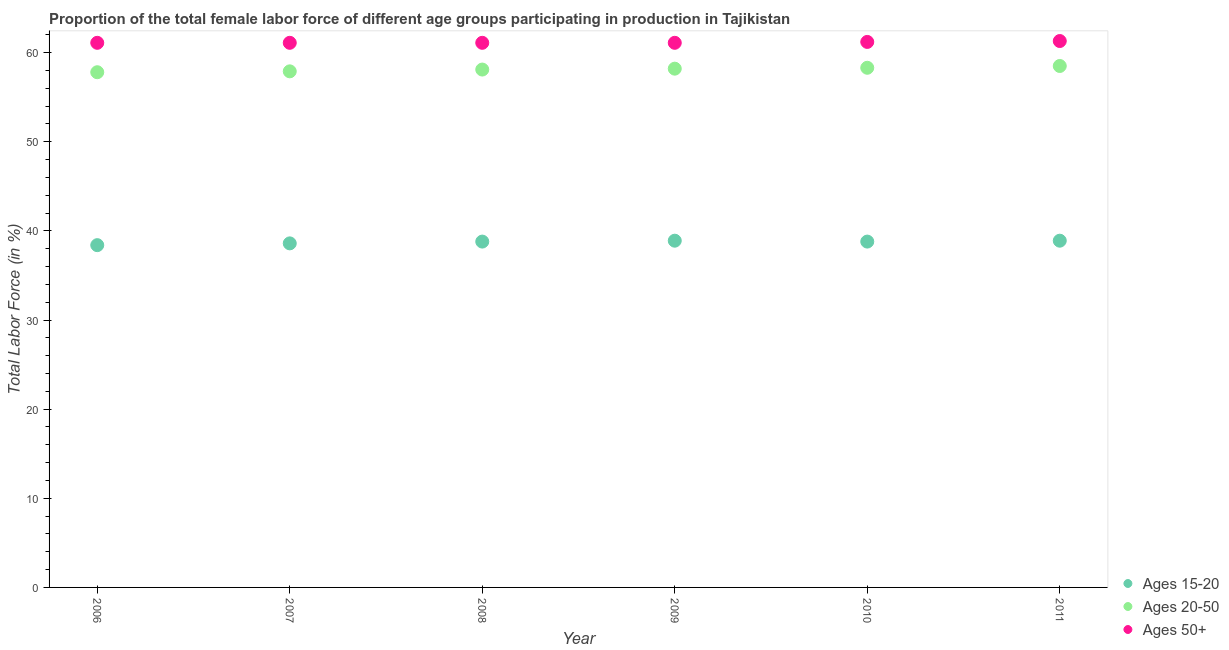How many different coloured dotlines are there?
Keep it short and to the point. 3. What is the percentage of female labor force within the age group 20-50 in 2009?
Your answer should be very brief. 58.2. Across all years, what is the maximum percentage of female labor force above age 50?
Provide a succinct answer. 61.3. Across all years, what is the minimum percentage of female labor force within the age group 15-20?
Keep it short and to the point. 38.4. In which year was the percentage of female labor force within the age group 15-20 minimum?
Give a very brief answer. 2006. What is the total percentage of female labor force within the age group 15-20 in the graph?
Your answer should be very brief. 232.4. What is the difference between the percentage of female labor force within the age group 20-50 in 2009 and that in 2010?
Your answer should be compact. -0.1. What is the difference between the percentage of female labor force within the age group 15-20 in 2006 and the percentage of female labor force within the age group 20-50 in 2009?
Your answer should be compact. -19.8. What is the average percentage of female labor force above age 50 per year?
Provide a succinct answer. 61.15. In the year 2008, what is the difference between the percentage of female labor force above age 50 and percentage of female labor force within the age group 15-20?
Ensure brevity in your answer.  22.3. Is the difference between the percentage of female labor force within the age group 20-50 in 2008 and 2010 greater than the difference between the percentage of female labor force within the age group 15-20 in 2008 and 2010?
Make the answer very short. No. What is the difference between the highest and the second highest percentage of female labor force within the age group 20-50?
Make the answer very short. 0.2. What is the difference between the highest and the lowest percentage of female labor force within the age group 15-20?
Your answer should be very brief. 0.5. Is the sum of the percentage of female labor force within the age group 20-50 in 2006 and 2010 greater than the maximum percentage of female labor force above age 50 across all years?
Make the answer very short. Yes. Does the percentage of female labor force above age 50 monotonically increase over the years?
Ensure brevity in your answer.  No. How many years are there in the graph?
Provide a succinct answer. 6. What is the difference between two consecutive major ticks on the Y-axis?
Your answer should be compact. 10. Where does the legend appear in the graph?
Your answer should be very brief. Bottom right. How many legend labels are there?
Your answer should be compact. 3. How are the legend labels stacked?
Your answer should be compact. Vertical. What is the title of the graph?
Provide a succinct answer. Proportion of the total female labor force of different age groups participating in production in Tajikistan. What is the label or title of the Y-axis?
Your response must be concise. Total Labor Force (in %). What is the Total Labor Force (in %) of Ages 15-20 in 2006?
Provide a succinct answer. 38.4. What is the Total Labor Force (in %) of Ages 20-50 in 2006?
Your answer should be compact. 57.8. What is the Total Labor Force (in %) of Ages 50+ in 2006?
Ensure brevity in your answer.  61.1. What is the Total Labor Force (in %) of Ages 15-20 in 2007?
Your answer should be compact. 38.6. What is the Total Labor Force (in %) of Ages 20-50 in 2007?
Your answer should be compact. 57.9. What is the Total Labor Force (in %) in Ages 50+ in 2007?
Keep it short and to the point. 61.1. What is the Total Labor Force (in %) in Ages 15-20 in 2008?
Your response must be concise. 38.8. What is the Total Labor Force (in %) in Ages 20-50 in 2008?
Keep it short and to the point. 58.1. What is the Total Labor Force (in %) in Ages 50+ in 2008?
Make the answer very short. 61.1. What is the Total Labor Force (in %) of Ages 15-20 in 2009?
Offer a very short reply. 38.9. What is the Total Labor Force (in %) in Ages 20-50 in 2009?
Ensure brevity in your answer.  58.2. What is the Total Labor Force (in %) in Ages 50+ in 2009?
Give a very brief answer. 61.1. What is the Total Labor Force (in %) in Ages 15-20 in 2010?
Offer a very short reply. 38.8. What is the Total Labor Force (in %) of Ages 20-50 in 2010?
Your response must be concise. 58.3. What is the Total Labor Force (in %) in Ages 50+ in 2010?
Provide a short and direct response. 61.2. What is the Total Labor Force (in %) in Ages 15-20 in 2011?
Make the answer very short. 38.9. What is the Total Labor Force (in %) in Ages 20-50 in 2011?
Make the answer very short. 58.5. What is the Total Labor Force (in %) of Ages 50+ in 2011?
Provide a short and direct response. 61.3. Across all years, what is the maximum Total Labor Force (in %) in Ages 15-20?
Offer a very short reply. 38.9. Across all years, what is the maximum Total Labor Force (in %) in Ages 20-50?
Provide a succinct answer. 58.5. Across all years, what is the maximum Total Labor Force (in %) of Ages 50+?
Make the answer very short. 61.3. Across all years, what is the minimum Total Labor Force (in %) of Ages 15-20?
Offer a terse response. 38.4. Across all years, what is the minimum Total Labor Force (in %) in Ages 20-50?
Make the answer very short. 57.8. Across all years, what is the minimum Total Labor Force (in %) in Ages 50+?
Give a very brief answer. 61.1. What is the total Total Labor Force (in %) in Ages 15-20 in the graph?
Provide a short and direct response. 232.4. What is the total Total Labor Force (in %) in Ages 20-50 in the graph?
Your answer should be compact. 348.8. What is the total Total Labor Force (in %) in Ages 50+ in the graph?
Offer a very short reply. 366.9. What is the difference between the Total Labor Force (in %) in Ages 20-50 in 2006 and that in 2007?
Ensure brevity in your answer.  -0.1. What is the difference between the Total Labor Force (in %) of Ages 50+ in 2006 and that in 2007?
Your answer should be very brief. 0. What is the difference between the Total Labor Force (in %) of Ages 50+ in 2006 and that in 2008?
Provide a succinct answer. 0. What is the difference between the Total Labor Force (in %) of Ages 15-20 in 2006 and that in 2009?
Give a very brief answer. -0.5. What is the difference between the Total Labor Force (in %) in Ages 20-50 in 2006 and that in 2009?
Offer a very short reply. -0.4. What is the difference between the Total Labor Force (in %) of Ages 50+ in 2006 and that in 2009?
Provide a short and direct response. 0. What is the difference between the Total Labor Force (in %) of Ages 15-20 in 2006 and that in 2011?
Ensure brevity in your answer.  -0.5. What is the difference between the Total Labor Force (in %) in Ages 20-50 in 2006 and that in 2011?
Ensure brevity in your answer.  -0.7. What is the difference between the Total Labor Force (in %) of Ages 50+ in 2007 and that in 2008?
Make the answer very short. 0. What is the difference between the Total Labor Force (in %) in Ages 15-20 in 2007 and that in 2009?
Your answer should be compact. -0.3. What is the difference between the Total Labor Force (in %) of Ages 20-50 in 2007 and that in 2010?
Keep it short and to the point. -0.4. What is the difference between the Total Labor Force (in %) in Ages 20-50 in 2008 and that in 2009?
Offer a terse response. -0.1. What is the difference between the Total Labor Force (in %) in Ages 50+ in 2008 and that in 2009?
Provide a succinct answer. 0. What is the difference between the Total Labor Force (in %) in Ages 15-20 in 2008 and that in 2010?
Offer a terse response. 0. What is the difference between the Total Labor Force (in %) in Ages 50+ in 2008 and that in 2010?
Your response must be concise. -0.1. What is the difference between the Total Labor Force (in %) in Ages 15-20 in 2008 and that in 2011?
Ensure brevity in your answer.  -0.1. What is the difference between the Total Labor Force (in %) of Ages 20-50 in 2008 and that in 2011?
Offer a very short reply. -0.4. What is the difference between the Total Labor Force (in %) in Ages 15-20 in 2009 and that in 2010?
Your response must be concise. 0.1. What is the difference between the Total Labor Force (in %) in Ages 15-20 in 2009 and that in 2011?
Your response must be concise. 0. What is the difference between the Total Labor Force (in %) in Ages 20-50 in 2009 and that in 2011?
Offer a terse response. -0.3. What is the difference between the Total Labor Force (in %) in Ages 15-20 in 2006 and the Total Labor Force (in %) in Ages 20-50 in 2007?
Offer a terse response. -19.5. What is the difference between the Total Labor Force (in %) of Ages 15-20 in 2006 and the Total Labor Force (in %) of Ages 50+ in 2007?
Make the answer very short. -22.7. What is the difference between the Total Labor Force (in %) in Ages 15-20 in 2006 and the Total Labor Force (in %) in Ages 20-50 in 2008?
Ensure brevity in your answer.  -19.7. What is the difference between the Total Labor Force (in %) in Ages 15-20 in 2006 and the Total Labor Force (in %) in Ages 50+ in 2008?
Give a very brief answer. -22.7. What is the difference between the Total Labor Force (in %) of Ages 20-50 in 2006 and the Total Labor Force (in %) of Ages 50+ in 2008?
Make the answer very short. -3.3. What is the difference between the Total Labor Force (in %) of Ages 15-20 in 2006 and the Total Labor Force (in %) of Ages 20-50 in 2009?
Provide a succinct answer. -19.8. What is the difference between the Total Labor Force (in %) of Ages 15-20 in 2006 and the Total Labor Force (in %) of Ages 50+ in 2009?
Your answer should be very brief. -22.7. What is the difference between the Total Labor Force (in %) in Ages 15-20 in 2006 and the Total Labor Force (in %) in Ages 20-50 in 2010?
Give a very brief answer. -19.9. What is the difference between the Total Labor Force (in %) of Ages 15-20 in 2006 and the Total Labor Force (in %) of Ages 50+ in 2010?
Ensure brevity in your answer.  -22.8. What is the difference between the Total Labor Force (in %) of Ages 15-20 in 2006 and the Total Labor Force (in %) of Ages 20-50 in 2011?
Offer a very short reply. -20.1. What is the difference between the Total Labor Force (in %) in Ages 15-20 in 2006 and the Total Labor Force (in %) in Ages 50+ in 2011?
Offer a terse response. -22.9. What is the difference between the Total Labor Force (in %) of Ages 15-20 in 2007 and the Total Labor Force (in %) of Ages 20-50 in 2008?
Offer a very short reply. -19.5. What is the difference between the Total Labor Force (in %) of Ages 15-20 in 2007 and the Total Labor Force (in %) of Ages 50+ in 2008?
Provide a succinct answer. -22.5. What is the difference between the Total Labor Force (in %) of Ages 20-50 in 2007 and the Total Labor Force (in %) of Ages 50+ in 2008?
Offer a very short reply. -3.2. What is the difference between the Total Labor Force (in %) in Ages 15-20 in 2007 and the Total Labor Force (in %) in Ages 20-50 in 2009?
Keep it short and to the point. -19.6. What is the difference between the Total Labor Force (in %) of Ages 15-20 in 2007 and the Total Labor Force (in %) of Ages 50+ in 2009?
Your answer should be very brief. -22.5. What is the difference between the Total Labor Force (in %) of Ages 15-20 in 2007 and the Total Labor Force (in %) of Ages 20-50 in 2010?
Give a very brief answer. -19.7. What is the difference between the Total Labor Force (in %) of Ages 15-20 in 2007 and the Total Labor Force (in %) of Ages 50+ in 2010?
Your answer should be compact. -22.6. What is the difference between the Total Labor Force (in %) in Ages 20-50 in 2007 and the Total Labor Force (in %) in Ages 50+ in 2010?
Your response must be concise. -3.3. What is the difference between the Total Labor Force (in %) in Ages 15-20 in 2007 and the Total Labor Force (in %) in Ages 20-50 in 2011?
Your answer should be very brief. -19.9. What is the difference between the Total Labor Force (in %) in Ages 15-20 in 2007 and the Total Labor Force (in %) in Ages 50+ in 2011?
Ensure brevity in your answer.  -22.7. What is the difference between the Total Labor Force (in %) of Ages 15-20 in 2008 and the Total Labor Force (in %) of Ages 20-50 in 2009?
Make the answer very short. -19.4. What is the difference between the Total Labor Force (in %) of Ages 15-20 in 2008 and the Total Labor Force (in %) of Ages 50+ in 2009?
Offer a terse response. -22.3. What is the difference between the Total Labor Force (in %) in Ages 20-50 in 2008 and the Total Labor Force (in %) in Ages 50+ in 2009?
Keep it short and to the point. -3. What is the difference between the Total Labor Force (in %) in Ages 15-20 in 2008 and the Total Labor Force (in %) in Ages 20-50 in 2010?
Your answer should be very brief. -19.5. What is the difference between the Total Labor Force (in %) in Ages 15-20 in 2008 and the Total Labor Force (in %) in Ages 50+ in 2010?
Offer a terse response. -22.4. What is the difference between the Total Labor Force (in %) of Ages 20-50 in 2008 and the Total Labor Force (in %) of Ages 50+ in 2010?
Make the answer very short. -3.1. What is the difference between the Total Labor Force (in %) of Ages 15-20 in 2008 and the Total Labor Force (in %) of Ages 20-50 in 2011?
Give a very brief answer. -19.7. What is the difference between the Total Labor Force (in %) of Ages 15-20 in 2008 and the Total Labor Force (in %) of Ages 50+ in 2011?
Keep it short and to the point. -22.5. What is the difference between the Total Labor Force (in %) in Ages 20-50 in 2008 and the Total Labor Force (in %) in Ages 50+ in 2011?
Give a very brief answer. -3.2. What is the difference between the Total Labor Force (in %) in Ages 15-20 in 2009 and the Total Labor Force (in %) in Ages 20-50 in 2010?
Offer a very short reply. -19.4. What is the difference between the Total Labor Force (in %) in Ages 15-20 in 2009 and the Total Labor Force (in %) in Ages 50+ in 2010?
Provide a short and direct response. -22.3. What is the difference between the Total Labor Force (in %) in Ages 15-20 in 2009 and the Total Labor Force (in %) in Ages 20-50 in 2011?
Make the answer very short. -19.6. What is the difference between the Total Labor Force (in %) of Ages 15-20 in 2009 and the Total Labor Force (in %) of Ages 50+ in 2011?
Keep it short and to the point. -22.4. What is the difference between the Total Labor Force (in %) of Ages 20-50 in 2009 and the Total Labor Force (in %) of Ages 50+ in 2011?
Provide a succinct answer. -3.1. What is the difference between the Total Labor Force (in %) of Ages 15-20 in 2010 and the Total Labor Force (in %) of Ages 20-50 in 2011?
Provide a short and direct response. -19.7. What is the difference between the Total Labor Force (in %) of Ages 15-20 in 2010 and the Total Labor Force (in %) of Ages 50+ in 2011?
Provide a short and direct response. -22.5. What is the difference between the Total Labor Force (in %) in Ages 20-50 in 2010 and the Total Labor Force (in %) in Ages 50+ in 2011?
Provide a short and direct response. -3. What is the average Total Labor Force (in %) of Ages 15-20 per year?
Provide a short and direct response. 38.73. What is the average Total Labor Force (in %) of Ages 20-50 per year?
Your response must be concise. 58.13. What is the average Total Labor Force (in %) of Ages 50+ per year?
Offer a terse response. 61.15. In the year 2006, what is the difference between the Total Labor Force (in %) of Ages 15-20 and Total Labor Force (in %) of Ages 20-50?
Your response must be concise. -19.4. In the year 2006, what is the difference between the Total Labor Force (in %) of Ages 15-20 and Total Labor Force (in %) of Ages 50+?
Offer a very short reply. -22.7. In the year 2007, what is the difference between the Total Labor Force (in %) of Ages 15-20 and Total Labor Force (in %) of Ages 20-50?
Give a very brief answer. -19.3. In the year 2007, what is the difference between the Total Labor Force (in %) in Ages 15-20 and Total Labor Force (in %) in Ages 50+?
Keep it short and to the point. -22.5. In the year 2007, what is the difference between the Total Labor Force (in %) of Ages 20-50 and Total Labor Force (in %) of Ages 50+?
Give a very brief answer. -3.2. In the year 2008, what is the difference between the Total Labor Force (in %) of Ages 15-20 and Total Labor Force (in %) of Ages 20-50?
Give a very brief answer. -19.3. In the year 2008, what is the difference between the Total Labor Force (in %) in Ages 15-20 and Total Labor Force (in %) in Ages 50+?
Offer a terse response. -22.3. In the year 2009, what is the difference between the Total Labor Force (in %) in Ages 15-20 and Total Labor Force (in %) in Ages 20-50?
Ensure brevity in your answer.  -19.3. In the year 2009, what is the difference between the Total Labor Force (in %) of Ages 15-20 and Total Labor Force (in %) of Ages 50+?
Ensure brevity in your answer.  -22.2. In the year 2009, what is the difference between the Total Labor Force (in %) of Ages 20-50 and Total Labor Force (in %) of Ages 50+?
Provide a short and direct response. -2.9. In the year 2010, what is the difference between the Total Labor Force (in %) of Ages 15-20 and Total Labor Force (in %) of Ages 20-50?
Give a very brief answer. -19.5. In the year 2010, what is the difference between the Total Labor Force (in %) in Ages 15-20 and Total Labor Force (in %) in Ages 50+?
Provide a short and direct response. -22.4. In the year 2010, what is the difference between the Total Labor Force (in %) of Ages 20-50 and Total Labor Force (in %) of Ages 50+?
Provide a short and direct response. -2.9. In the year 2011, what is the difference between the Total Labor Force (in %) of Ages 15-20 and Total Labor Force (in %) of Ages 20-50?
Provide a short and direct response. -19.6. In the year 2011, what is the difference between the Total Labor Force (in %) of Ages 15-20 and Total Labor Force (in %) of Ages 50+?
Your answer should be very brief. -22.4. In the year 2011, what is the difference between the Total Labor Force (in %) in Ages 20-50 and Total Labor Force (in %) in Ages 50+?
Your answer should be compact. -2.8. What is the ratio of the Total Labor Force (in %) in Ages 15-20 in 2006 to that in 2007?
Ensure brevity in your answer.  0.99. What is the ratio of the Total Labor Force (in %) in Ages 20-50 in 2006 to that in 2007?
Your answer should be very brief. 1. What is the ratio of the Total Labor Force (in %) in Ages 50+ in 2006 to that in 2007?
Offer a terse response. 1. What is the ratio of the Total Labor Force (in %) in Ages 15-20 in 2006 to that in 2009?
Ensure brevity in your answer.  0.99. What is the ratio of the Total Labor Force (in %) of Ages 20-50 in 2006 to that in 2010?
Your response must be concise. 0.99. What is the ratio of the Total Labor Force (in %) in Ages 50+ in 2006 to that in 2010?
Offer a very short reply. 1. What is the ratio of the Total Labor Force (in %) in Ages 15-20 in 2006 to that in 2011?
Provide a succinct answer. 0.99. What is the ratio of the Total Labor Force (in %) of Ages 50+ in 2006 to that in 2011?
Make the answer very short. 1. What is the ratio of the Total Labor Force (in %) in Ages 15-20 in 2007 to that in 2008?
Ensure brevity in your answer.  0.99. What is the ratio of the Total Labor Force (in %) of Ages 20-50 in 2007 to that in 2009?
Ensure brevity in your answer.  0.99. What is the ratio of the Total Labor Force (in %) in Ages 15-20 in 2007 to that in 2010?
Your answer should be compact. 0.99. What is the ratio of the Total Labor Force (in %) of Ages 50+ in 2007 to that in 2010?
Your answer should be very brief. 1. What is the ratio of the Total Labor Force (in %) of Ages 20-50 in 2008 to that in 2009?
Make the answer very short. 1. What is the ratio of the Total Labor Force (in %) of Ages 50+ in 2008 to that in 2009?
Provide a succinct answer. 1. What is the ratio of the Total Labor Force (in %) of Ages 15-20 in 2008 to that in 2010?
Offer a very short reply. 1. What is the ratio of the Total Labor Force (in %) of Ages 20-50 in 2008 to that in 2011?
Keep it short and to the point. 0.99. What is the ratio of the Total Labor Force (in %) of Ages 50+ in 2008 to that in 2011?
Make the answer very short. 1. What is the ratio of the Total Labor Force (in %) of Ages 15-20 in 2009 to that in 2010?
Your answer should be compact. 1. What is the ratio of the Total Labor Force (in %) in Ages 20-50 in 2009 to that in 2010?
Make the answer very short. 1. What is the ratio of the Total Labor Force (in %) in Ages 50+ in 2009 to that in 2010?
Provide a succinct answer. 1. What is the ratio of the Total Labor Force (in %) in Ages 15-20 in 2009 to that in 2011?
Ensure brevity in your answer.  1. What is the ratio of the Total Labor Force (in %) in Ages 50+ in 2009 to that in 2011?
Give a very brief answer. 1. What is the ratio of the Total Labor Force (in %) of Ages 15-20 in 2010 to that in 2011?
Provide a succinct answer. 1. What is the difference between the highest and the second highest Total Labor Force (in %) of Ages 15-20?
Your answer should be compact. 0. What is the difference between the highest and the second highest Total Labor Force (in %) in Ages 50+?
Your answer should be compact. 0.1. What is the difference between the highest and the lowest Total Labor Force (in %) in Ages 20-50?
Your answer should be compact. 0.7. 